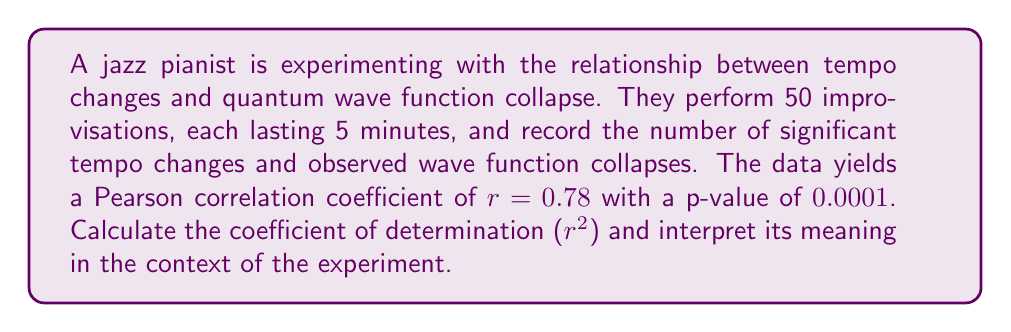Give your solution to this math problem. To solve this problem, we'll follow these steps:

1) The coefficient of determination ($r^2$) is the square of the Pearson correlation coefficient ($r$).

2) Given $r = 0.78$, we calculate $r^2$:

   $r^2 = (0.78)^2 = 0.6084$

3) Interpretation of $r^2$:
   - $r^2$ represents the proportion of variance in the dependent variable (wave function collapses) that is predictable from the independent variable (tempo changes).
   - It ranges from 0 to 1, where 1 indicates perfect prediction and 0 indicates no predictive power.
   - In this case, $r^2 = 0.6084$ means that approximately 60.84% of the variance in the number of observed wave function collapses can be explained by the variance in tempo changes.

4) The p-value of 0.0001 indicates that this correlation is statistically significant, as it's much smaller than the typical significance level of 0.05.

5) In the context of the experiment:
   - There is a strong positive correlation between tempo changes and wave function collapses.
   - About 60.84% of the variability in wave function collapses can be accounted for by changes in tempo.
   - This suggests that the pianist's tempo changes during improvisation have a substantial relationship with quantum phenomena, though other factors also play a role.
Answer: $r^2 = 0.6084$, indicating 60.84% of variance in wave function collapses is explained by tempo changes. 